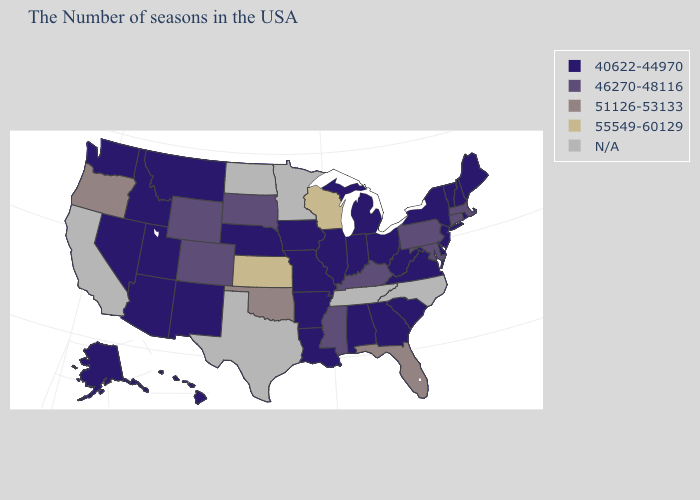What is the value of Delaware?
Answer briefly. 40622-44970. What is the value of Michigan?
Write a very short answer. 40622-44970. What is the value of Tennessee?
Write a very short answer. N/A. What is the value of Georgia?
Write a very short answer. 40622-44970. Does Ohio have the lowest value in the USA?
Answer briefly. Yes. Does the map have missing data?
Write a very short answer. Yes. Does Louisiana have the highest value in the USA?
Concise answer only. No. Name the states that have a value in the range N/A?
Answer briefly. North Carolina, Tennessee, Minnesota, Texas, North Dakota, California. Among the states that border Arkansas , which have the highest value?
Write a very short answer. Oklahoma. What is the highest value in the USA?
Be succinct. 55549-60129. What is the value of California?
Quick response, please. N/A. What is the value of Rhode Island?
Give a very brief answer. 40622-44970. What is the highest value in the USA?
Concise answer only. 55549-60129. What is the value of Idaho?
Keep it brief. 40622-44970. Name the states that have a value in the range 46270-48116?
Give a very brief answer. Massachusetts, Connecticut, Maryland, Pennsylvania, Kentucky, Mississippi, South Dakota, Wyoming, Colorado. 